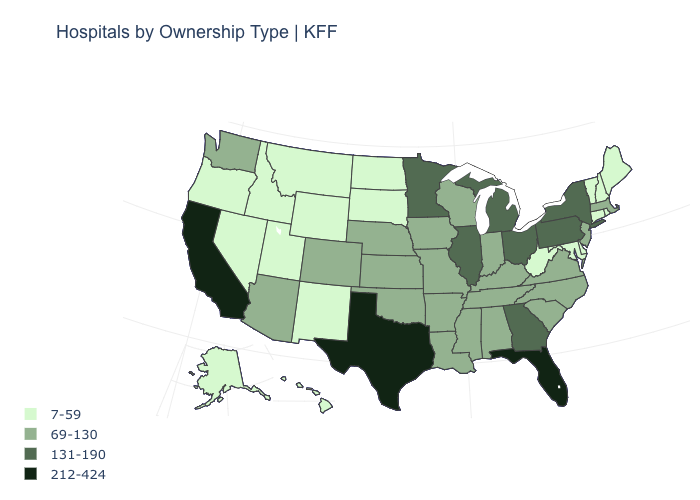What is the highest value in the USA?
Give a very brief answer. 212-424. What is the value of North Carolina?
Answer briefly. 69-130. Name the states that have a value in the range 7-59?
Concise answer only. Alaska, Connecticut, Delaware, Hawaii, Idaho, Maine, Maryland, Montana, Nevada, New Hampshire, New Mexico, North Dakota, Oregon, Rhode Island, South Dakota, Utah, Vermont, West Virginia, Wyoming. Name the states that have a value in the range 212-424?
Quick response, please. California, Florida, Texas. What is the value of Nebraska?
Be succinct. 69-130. Name the states that have a value in the range 7-59?
Give a very brief answer. Alaska, Connecticut, Delaware, Hawaii, Idaho, Maine, Maryland, Montana, Nevada, New Hampshire, New Mexico, North Dakota, Oregon, Rhode Island, South Dakota, Utah, Vermont, West Virginia, Wyoming. Name the states that have a value in the range 131-190?
Write a very short answer. Georgia, Illinois, Michigan, Minnesota, New York, Ohio, Pennsylvania. What is the value of West Virginia?
Be succinct. 7-59. Does Illinois have the same value as Indiana?
Keep it brief. No. Does Colorado have the highest value in the West?
Answer briefly. No. What is the value of Indiana?
Keep it brief. 69-130. What is the highest value in the MidWest ?
Give a very brief answer. 131-190. Does Wyoming have the same value as Alaska?
Short answer required. Yes. Does the map have missing data?
Short answer required. No. 